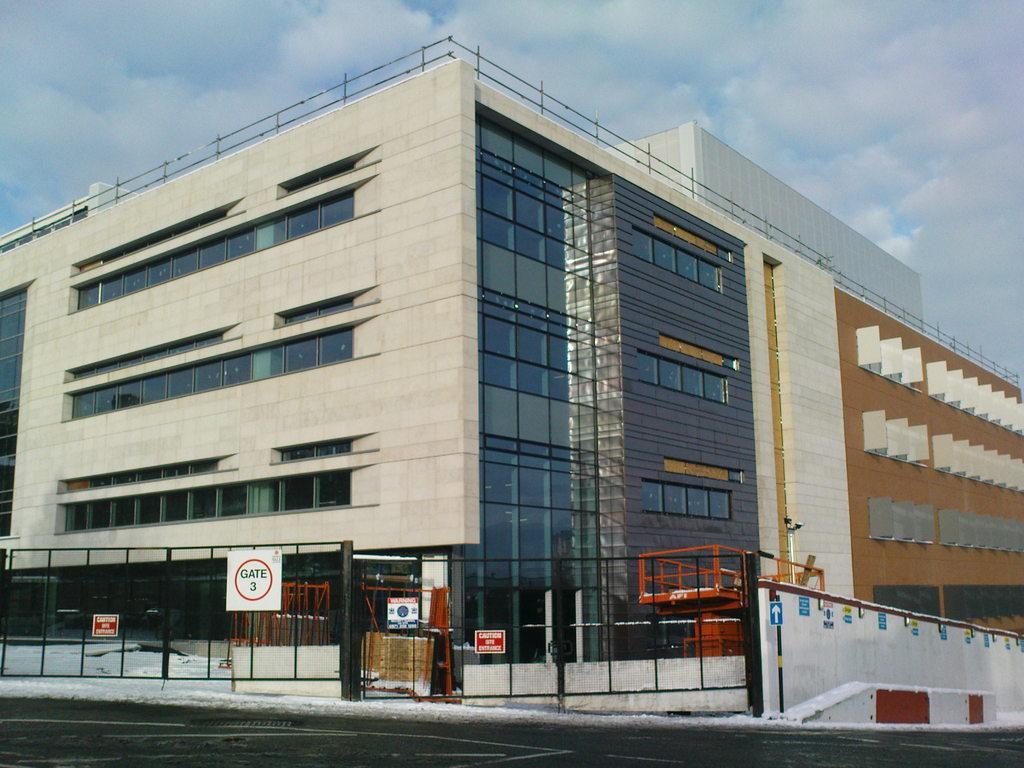Could you give a brief overview of what you see in this image? In this picture I can see some buildings, grills gate with the board and some text on the board. 